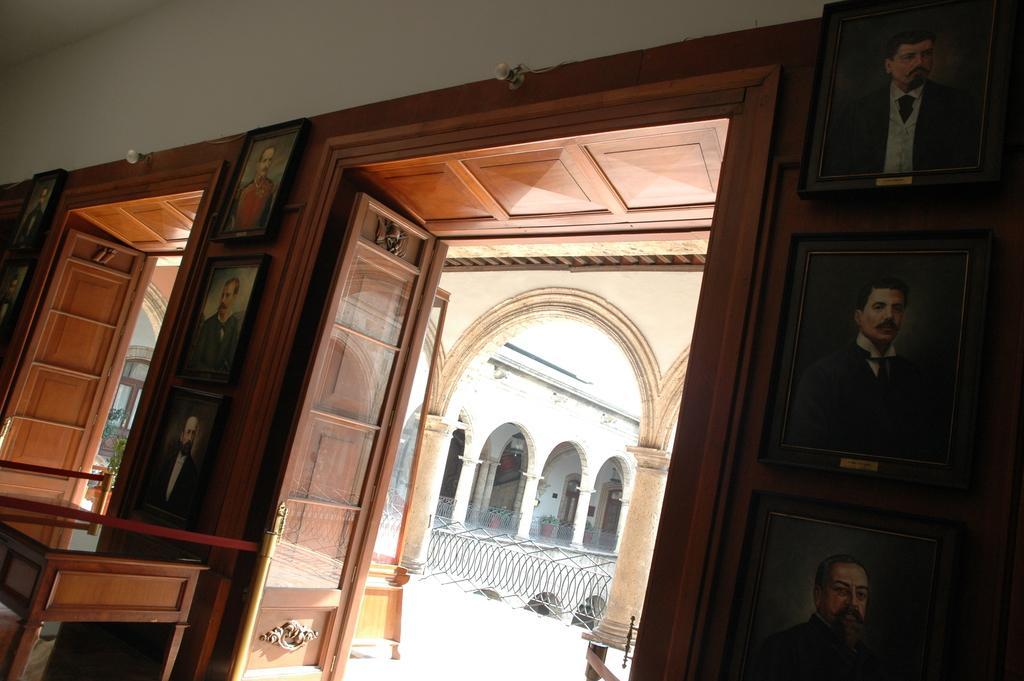In one or two sentences, can you explain what this image depicts? In this picture I can observe photo frames on the wall. There is a table on the left side. I can observe some doors. In the background there are pillars and a fence. 